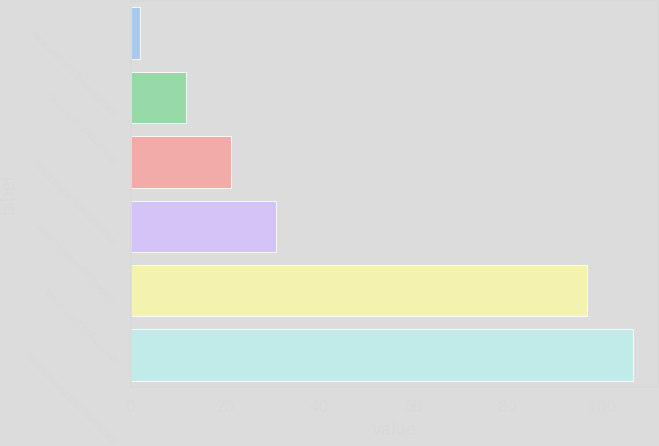Convert chart. <chart><loc_0><loc_0><loc_500><loc_500><bar_chart><fcel>Research and Development<fcel>Selling and Marketing<fcel>General and Administrative<fcel>Amortization of Intangible<fcel>Impairment of Goodwill<fcel>Restructuring and Divestiture<nl><fcel>2<fcel>11.6<fcel>21.2<fcel>30.8<fcel>97<fcel>106.6<nl></chart> 